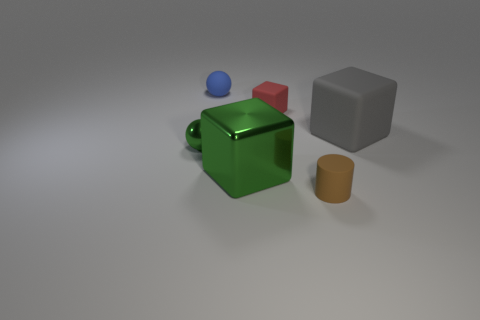Add 4 small shiny things. How many objects exist? 10 Subtract all green cubes. How many cubes are left? 2 Subtract all blue spheres. How many spheres are left? 1 Subtract all big blue objects. Subtract all small brown matte cylinders. How many objects are left? 5 Add 6 small blue rubber things. How many small blue rubber things are left? 7 Add 1 large purple matte things. How many large purple matte things exist? 1 Subtract 0 brown spheres. How many objects are left? 6 Subtract all cylinders. How many objects are left? 5 Subtract 1 spheres. How many spheres are left? 1 Subtract all cyan blocks. Subtract all red balls. How many blocks are left? 3 